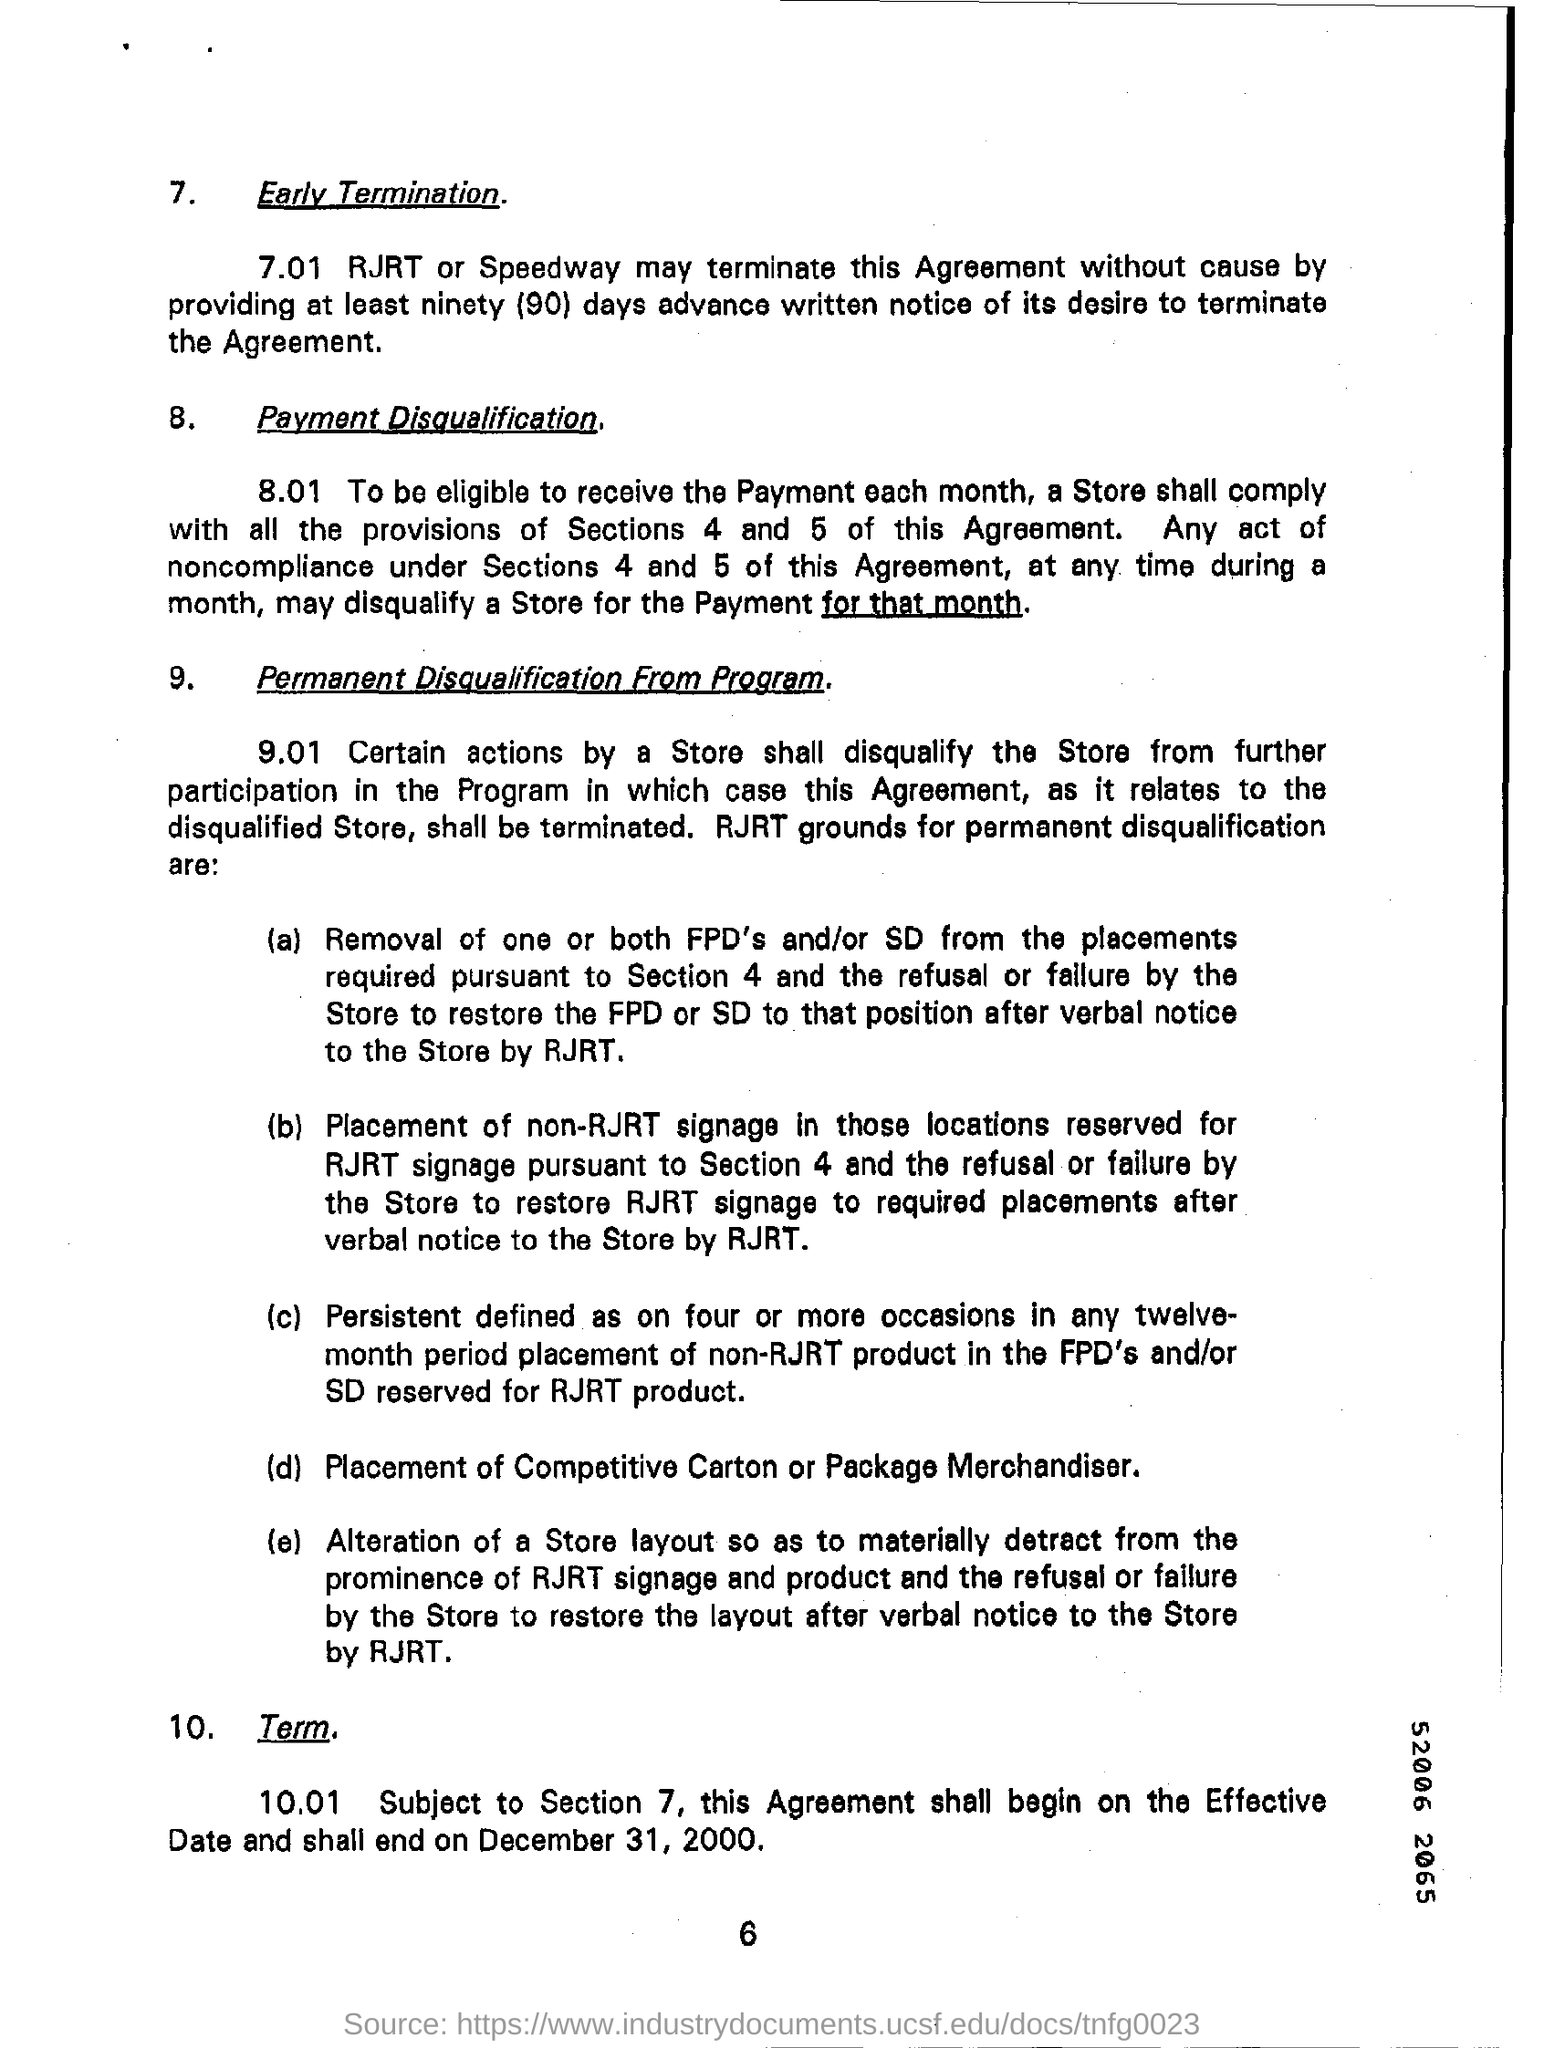Indicate a few pertinent items in this graphic. The agreement shall commence on the effective date and end on December 31, 2000, subject to the subject. The number at the bottom of the page is 6. 